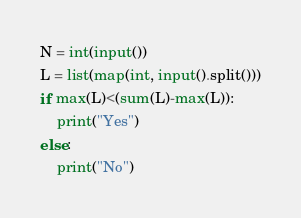<code> <loc_0><loc_0><loc_500><loc_500><_Python_>N = int(input())
L = list(map(int, input().split()))
if max(L)<(sum(L)-max(L)):
    print("Yes")
else:
    print("No")</code> 